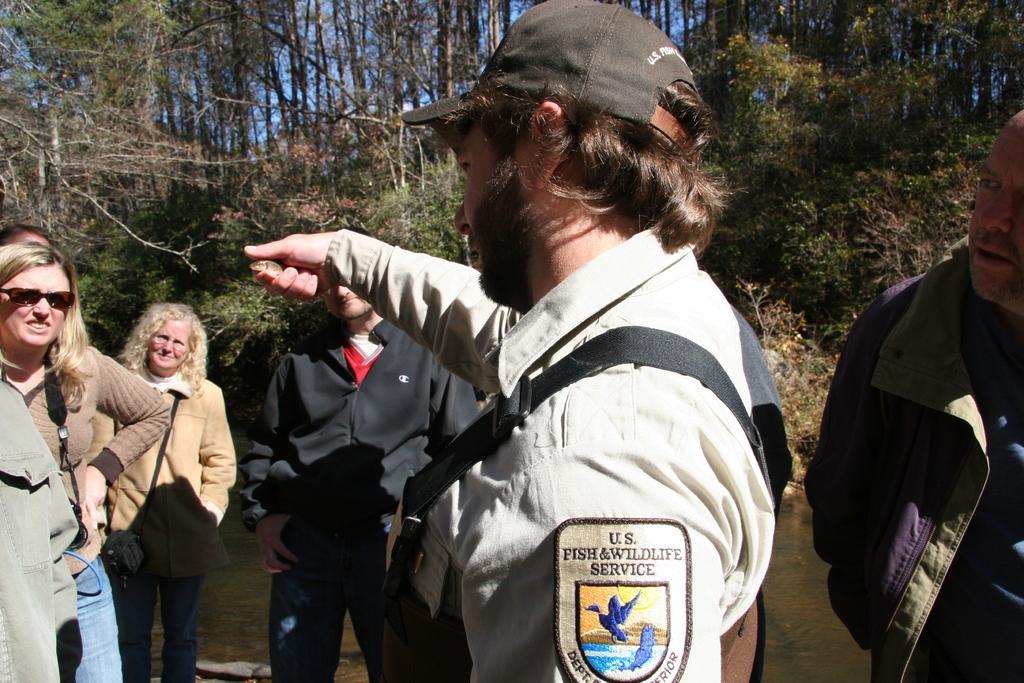Please provide a concise description of this image. In the center of the image a man is standing and holding an object and wearing cap, bag. In the background of the image we can see some persons are standing. At the top of the image we can see trees, sky. At the bottom of the image there is a ground. 